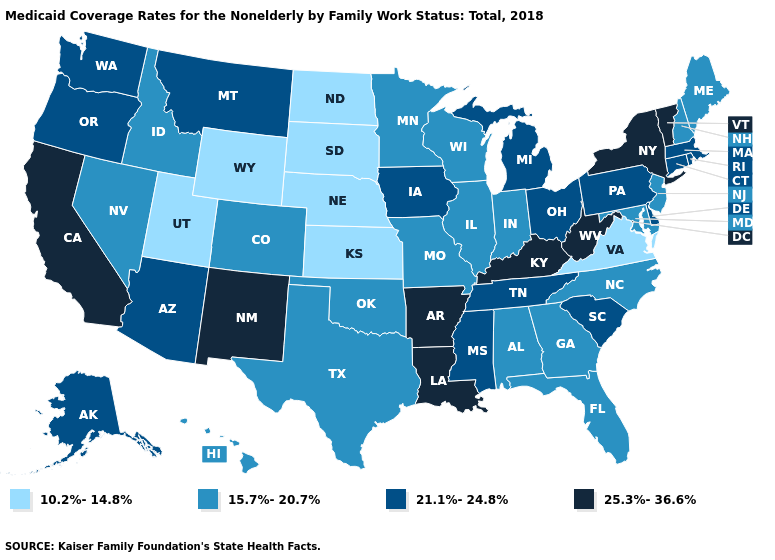Name the states that have a value in the range 25.3%-36.6%?
Concise answer only. Arkansas, California, Kentucky, Louisiana, New Mexico, New York, Vermont, West Virginia. What is the value of Delaware?
Answer briefly. 21.1%-24.8%. Is the legend a continuous bar?
Short answer required. No. What is the highest value in the USA?
Quick response, please. 25.3%-36.6%. Is the legend a continuous bar?
Short answer required. No. Among the states that border New Mexico , which have the highest value?
Be succinct. Arizona. Does Pennsylvania have the same value as Idaho?
Write a very short answer. No. Which states have the lowest value in the MidWest?
Write a very short answer. Kansas, Nebraska, North Dakota, South Dakota. Name the states that have a value in the range 21.1%-24.8%?
Answer briefly. Alaska, Arizona, Connecticut, Delaware, Iowa, Massachusetts, Michigan, Mississippi, Montana, Ohio, Oregon, Pennsylvania, Rhode Island, South Carolina, Tennessee, Washington. What is the value of North Dakota?
Be succinct. 10.2%-14.8%. Among the states that border Arizona , which have the lowest value?
Short answer required. Utah. Which states have the highest value in the USA?
Give a very brief answer. Arkansas, California, Kentucky, Louisiana, New Mexico, New York, Vermont, West Virginia. What is the value of Nevada?
Concise answer only. 15.7%-20.7%. What is the value of Alaska?
Give a very brief answer. 21.1%-24.8%. Is the legend a continuous bar?
Short answer required. No. 